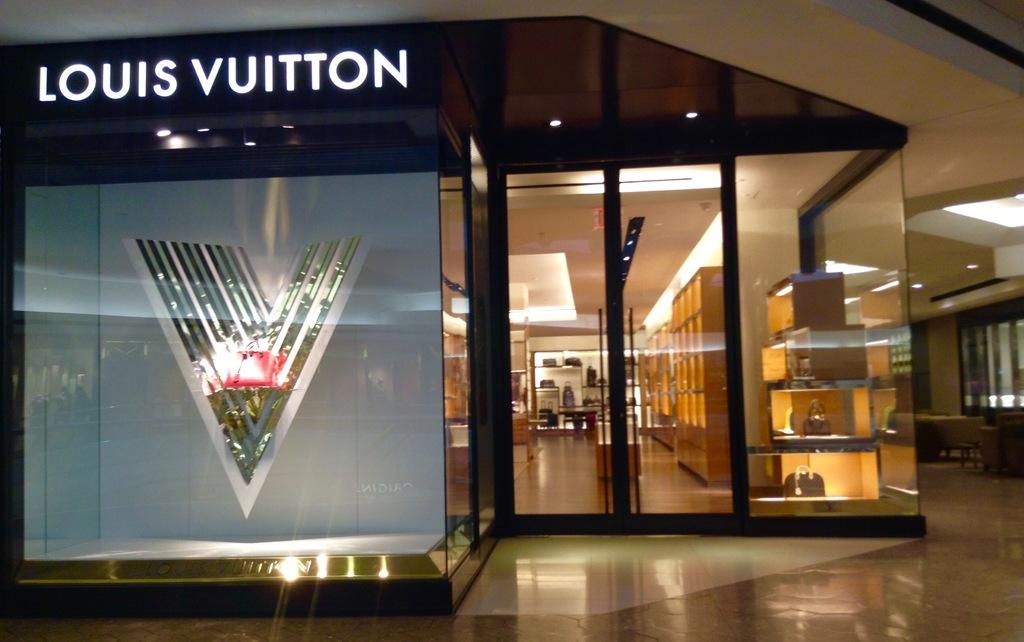Provide a one-sentence caption for the provided image. Louis Vuitton's store beamed with light and tempted with glimpses of the wares inside. 